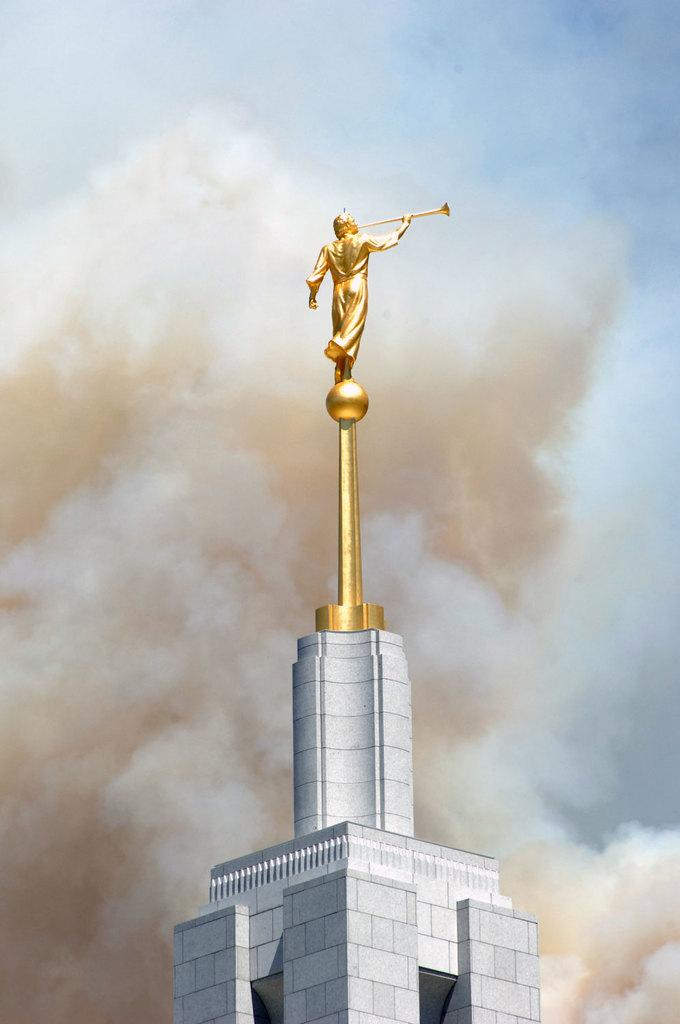What is the main subject in the center of the image? There is a sculpture on a building in the image, and it is in the center. Where is the sculpture located? The sculpture is on a building in the image. What can be seen in the background of the image? There is smoke in the sky in the background of the image. What type of game are the girls playing in the image? There are no girls or games present in the image; it features a sculpture on a building and smoke in the sky. 